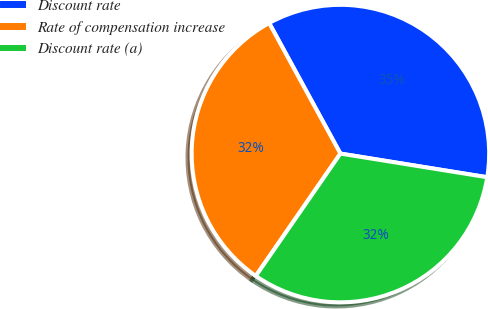Convert chart to OTSL. <chart><loc_0><loc_0><loc_500><loc_500><pie_chart><fcel>Discount rate<fcel>Rate of compensation increase<fcel>Discount rate (a)<nl><fcel>35.49%<fcel>32.42%<fcel>32.08%<nl></chart> 